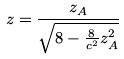Convert formula to latex. <formula><loc_0><loc_0><loc_500><loc_500>z = \frac { z _ { A } } { \sqrt { 8 - \frac { 8 } { c ^ { 2 } } z _ { A } ^ { 2 } } }</formula> 